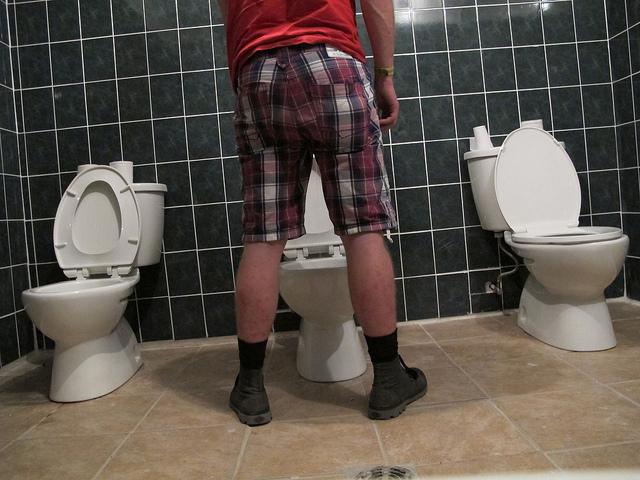How many drains are in this rest room's floor?
Keep it brief. 1. Is the man standing straight?
Short answer required. Yes. How many toilets is there?
Write a very short answer. 3. What is the person doing?
Quick response, please. Peeing. 